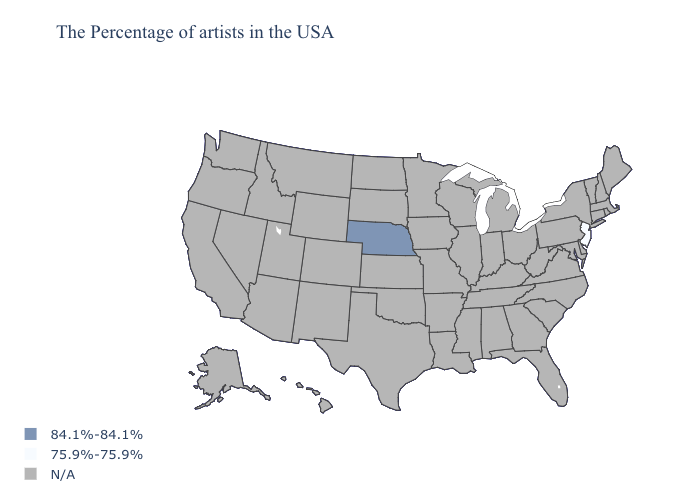What is the lowest value in the USA?
Give a very brief answer. 75.9%-75.9%. Name the states that have a value in the range N/A?
Keep it brief. Maine, Massachusetts, Rhode Island, New Hampshire, Vermont, Connecticut, New York, Delaware, Maryland, Pennsylvania, Virginia, North Carolina, South Carolina, West Virginia, Ohio, Florida, Georgia, Michigan, Kentucky, Indiana, Alabama, Tennessee, Wisconsin, Illinois, Mississippi, Louisiana, Missouri, Arkansas, Minnesota, Iowa, Kansas, Oklahoma, Texas, South Dakota, North Dakota, Wyoming, Colorado, New Mexico, Utah, Montana, Arizona, Idaho, Nevada, California, Washington, Oregon, Alaska, Hawaii. How many symbols are there in the legend?
Short answer required. 3. What is the highest value in the USA?
Keep it brief. 84.1%-84.1%. What is the value of Oregon?
Give a very brief answer. N/A. How many symbols are there in the legend?
Write a very short answer. 3. Does Nebraska have the lowest value in the USA?
Be succinct. No. Does the first symbol in the legend represent the smallest category?
Short answer required. No. Does Nebraska have the highest value in the USA?
Concise answer only. Yes. Name the states that have a value in the range N/A?
Answer briefly. Maine, Massachusetts, Rhode Island, New Hampshire, Vermont, Connecticut, New York, Delaware, Maryland, Pennsylvania, Virginia, North Carolina, South Carolina, West Virginia, Ohio, Florida, Georgia, Michigan, Kentucky, Indiana, Alabama, Tennessee, Wisconsin, Illinois, Mississippi, Louisiana, Missouri, Arkansas, Minnesota, Iowa, Kansas, Oklahoma, Texas, South Dakota, North Dakota, Wyoming, Colorado, New Mexico, Utah, Montana, Arizona, Idaho, Nevada, California, Washington, Oregon, Alaska, Hawaii. 